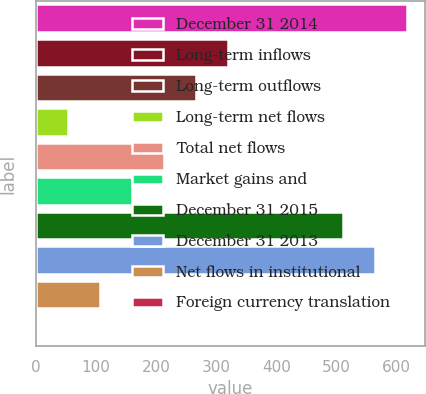Convert chart to OTSL. <chart><loc_0><loc_0><loc_500><loc_500><bar_chart><fcel>December 31 2014<fcel>Long-term inflows<fcel>Long-term outflows<fcel>Long-term net flows<fcel>Total net flows<fcel>Market gains and<fcel>December 31 2015<fcel>December 31 2013<fcel>Net flows in institutional<fcel>Foreign currency translation<nl><fcel>617.1<fcel>319.3<fcel>266.1<fcel>53.3<fcel>212.9<fcel>159.7<fcel>510.7<fcel>563.9<fcel>106.5<fcel>0.1<nl></chart> 